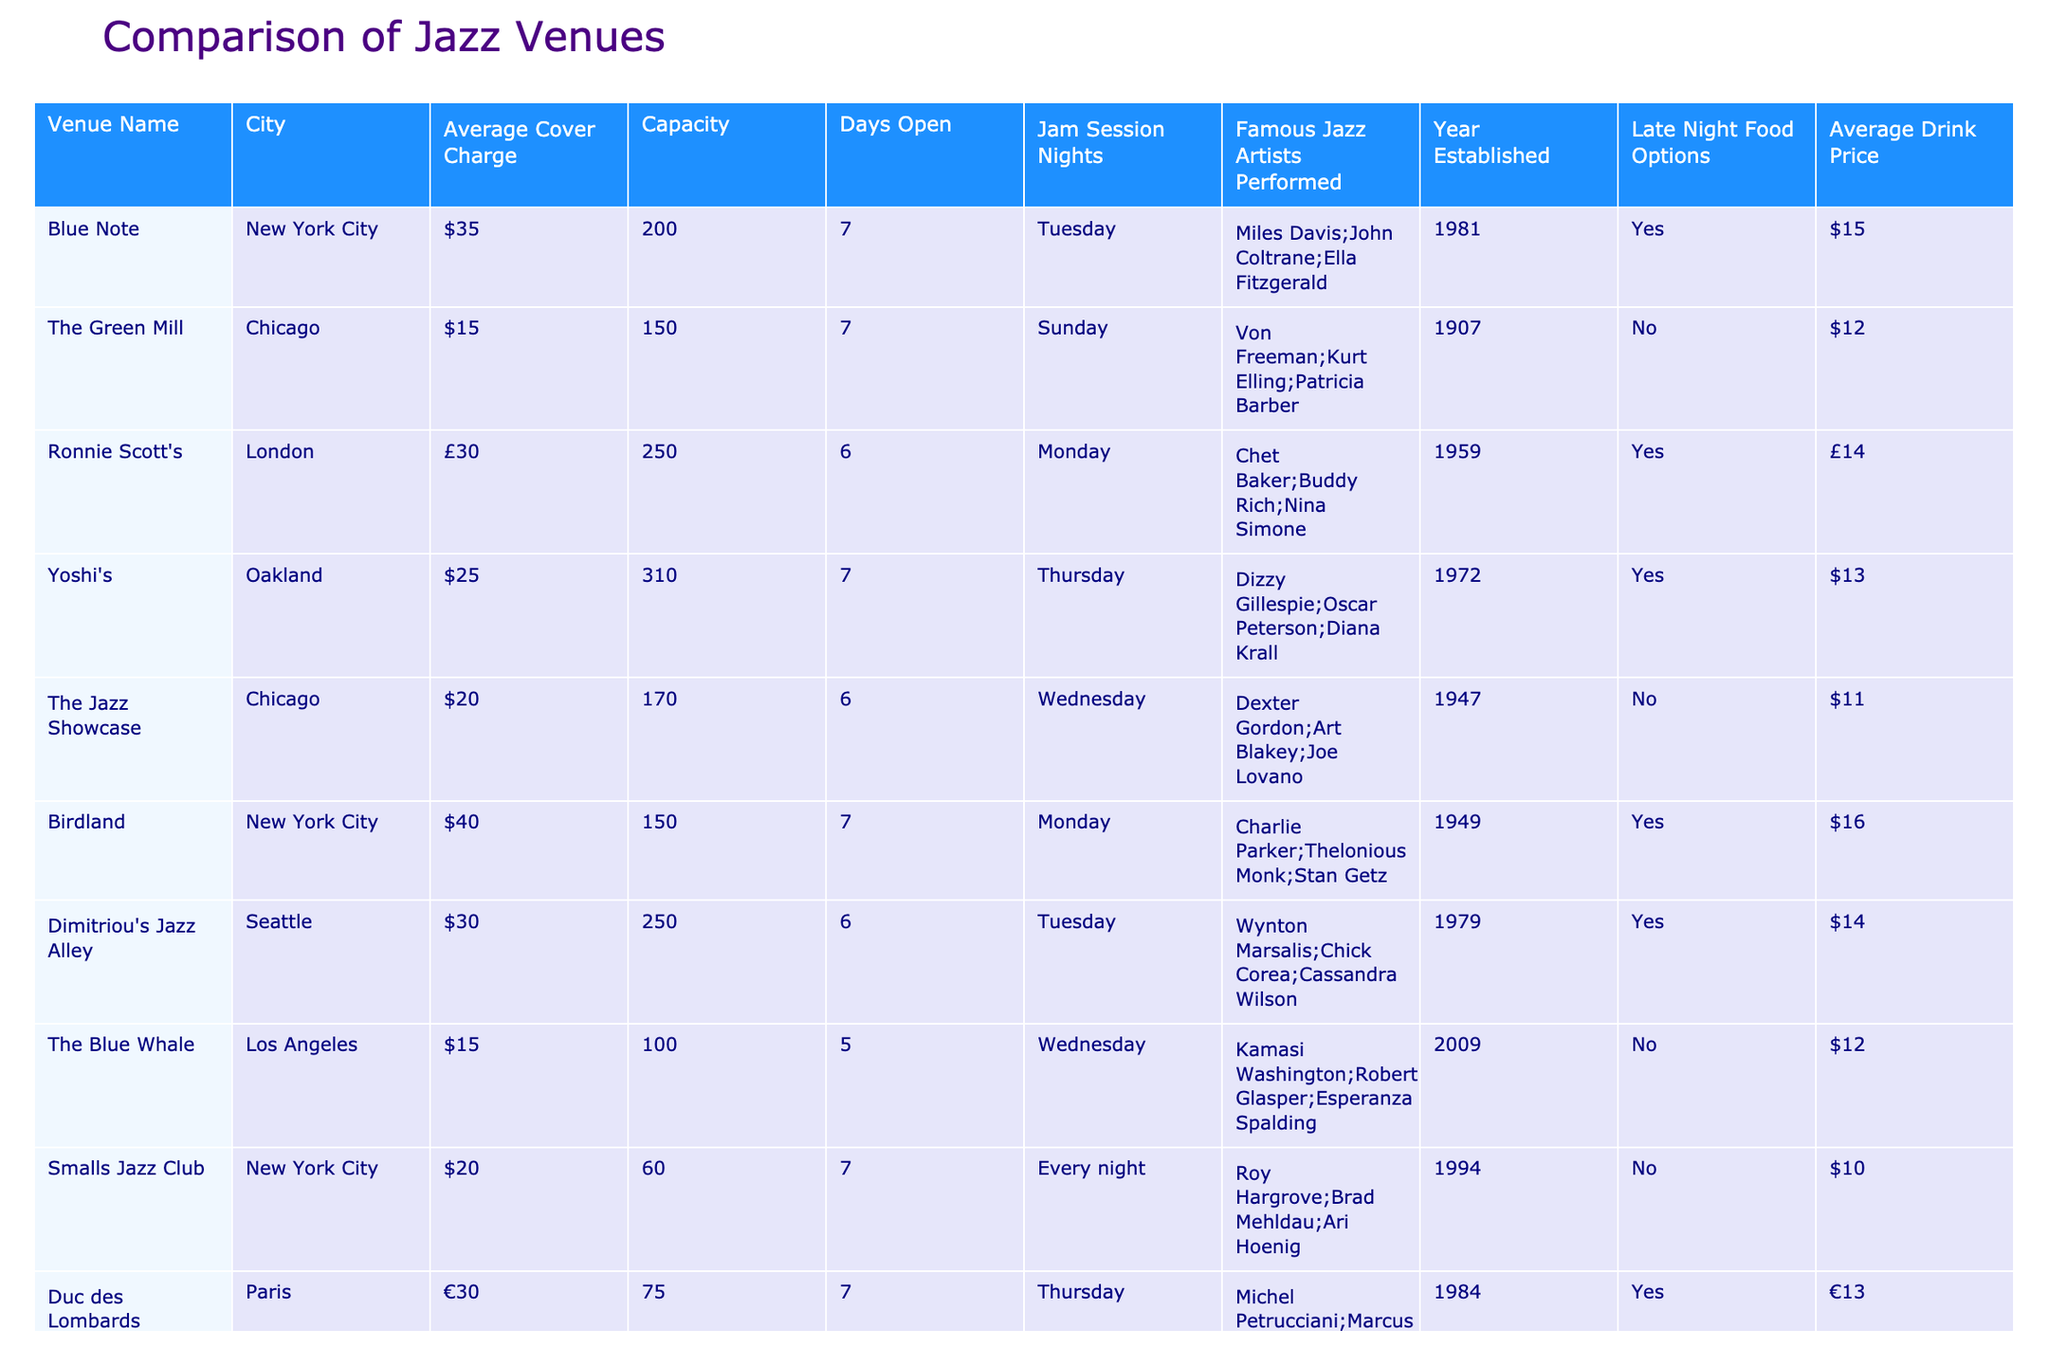What is the average cover charge of jazz venues in Chicago? There are two venues in Chicago listed: The Green Mill with a cover charge of $15 and The Jazz Showcase with a cover charge of $20. To find the average, we sum these values: 15 + 20 = 35, then divide by the number of venues, which is 2. Thus, the average cover charge = 35 / 2 = 17.50
Answer: $17.50 Which venue has the highest capacity? Looking at the capacity column, Yoshi's in Oakland has the highest capacity at 310, compared to other venues like Birdland in New York City with 150 and Ronnie Scott's in London with 250.
Answer: Yoshi's Is there a venue in Seattle that has late night food options? The table lists Dimitriou's Jazz Alley in Seattle, which does have late night food options, as indicated by "Yes" in the Late Night Food Options column.
Answer: Yes How many days a week is Smalls Jazz Club open? Smalls Jazz Club is open every night, which implies it operates for 7 days a week. This matches with the Days Open column showing "7".
Answer: 7 What is the total average drink price of the jazz venues located in New York City? There are three venues in New York City: Blue Note ($15), Birdland ($16), and Smalls Jazz Club ($10). To find the total average, we add these drink prices: 15 + 16 + 10 = 41. Next, we divide by the number of venues, which is 3. Thus, the average drink price = 41 / 3 ≈ 13.67
Answer: $13.67 Which jazz venue has hosted the most famous artists? The table does not quantify the number of famous artists per venue; however, venues like Blue Note and Birdland mention multiple famous artists in their respective entries. While multiple artists are noted, a definitive count across all venues would require counting mentions. Blue Note's artists include Miles Davis, John Coltrane, and Ella Fitzgerald, making it notable.
Answer: Blue Note Is there a venue in Paris that has a jam session night? According to the table, Duc des Lombards in Paris has a jam session night on Thursdays, indicated by "Thursday" under the Jam Session Nights column.
Answer: Yes What is the difference in average cover charge between the venues in New York City and those in Chicago? For New York City venues, the cover charges are $35 (Blue Note) and $40 (Birdland), averaging to (35 + 40) / 2 = 37.50. For Chicago venues, it's $15 (The Green Mill) and $20 (The Jazz Showcase), averaging to (15 + 20) / 2 = 17.50. The difference in averages is 37.50 - 17.50 = 20.
Answer: $20 Which city has jazz venues with both late night food options and jam session nights? By examining the table, we see that Yoshi's in Oakland is marked with "Yes" for late night food options and has a jam session on Thursday. This makes Oakland the city where the criteria are met.
Answer: Oakland 